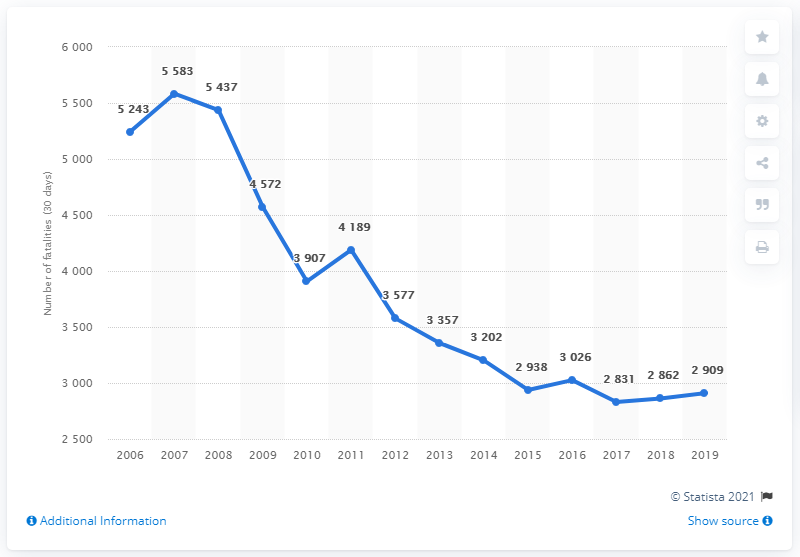Point out several critical features in this image. In the year 2007, the highest number of road fatalities occurred in Poland. In 2019, 2,909 people lost their lives in motor vehicle accidents in Poland. 